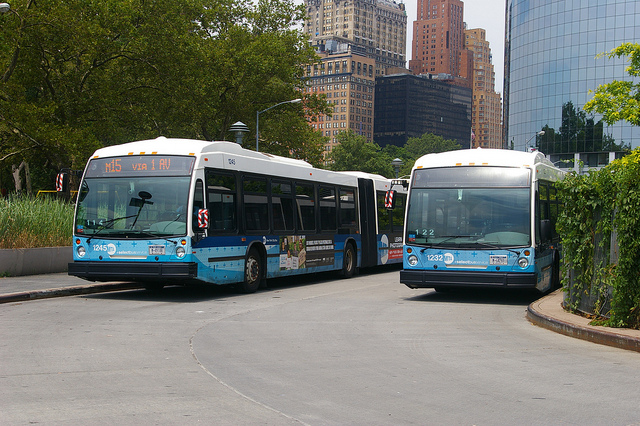Identify the text displayed in this image. 122 1232 1345 M15 